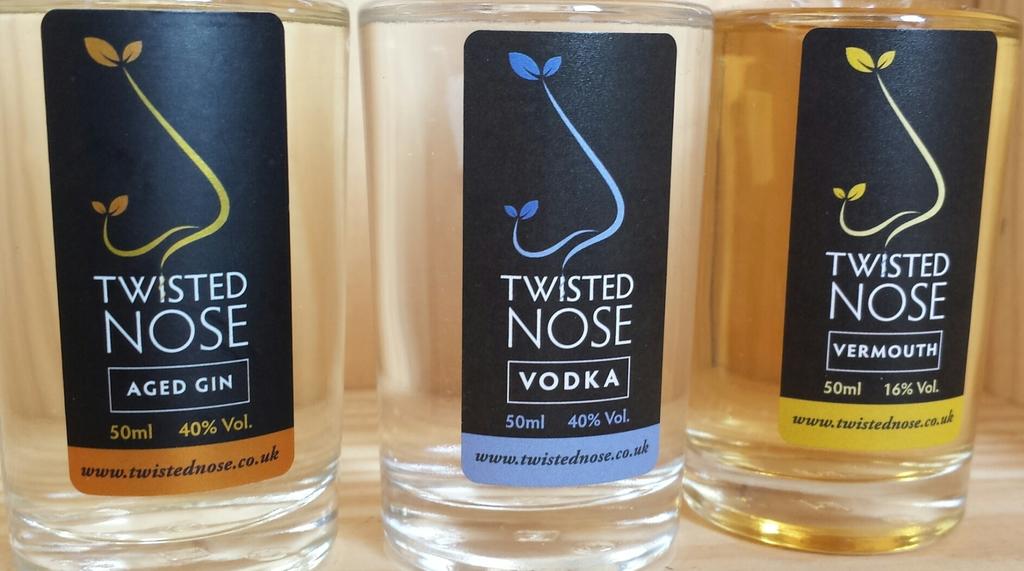What percent of alcohol is the vermouth?
Provide a succinct answer. 40%. What is in the middle bottle?
Provide a succinct answer. Vodka. 